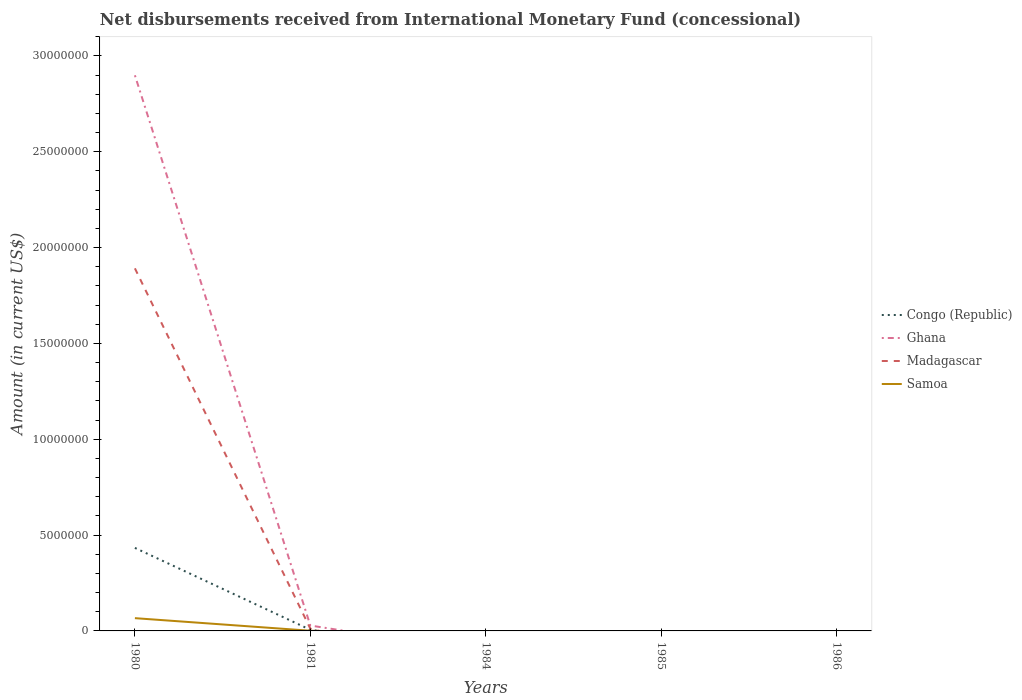How many different coloured lines are there?
Your answer should be compact. 4. Does the line corresponding to Congo (Republic) intersect with the line corresponding to Ghana?
Your response must be concise. Yes. Across all years, what is the maximum amount of disbursements received from International Monetary Fund in Madagascar?
Your answer should be compact. 0. What is the difference between the highest and the second highest amount of disbursements received from International Monetary Fund in Madagascar?
Provide a succinct answer. 1.89e+07. What is the difference between the highest and the lowest amount of disbursements received from International Monetary Fund in Congo (Republic)?
Your answer should be very brief. 1. What is the difference between two consecutive major ticks on the Y-axis?
Your answer should be compact. 5.00e+06. Are the values on the major ticks of Y-axis written in scientific E-notation?
Provide a succinct answer. No. Does the graph contain any zero values?
Ensure brevity in your answer.  Yes. Does the graph contain grids?
Make the answer very short. No. How many legend labels are there?
Your answer should be very brief. 4. What is the title of the graph?
Offer a very short reply. Net disbursements received from International Monetary Fund (concessional). What is the label or title of the X-axis?
Offer a terse response. Years. What is the Amount (in current US$) of Congo (Republic) in 1980?
Your response must be concise. 4.33e+06. What is the Amount (in current US$) in Ghana in 1980?
Provide a short and direct response. 2.90e+07. What is the Amount (in current US$) of Madagascar in 1980?
Provide a succinct answer. 1.89e+07. What is the Amount (in current US$) in Samoa in 1980?
Your answer should be compact. 6.66e+05. What is the Amount (in current US$) of Congo (Republic) in 1981?
Keep it short and to the point. 5.80e+04. What is the Amount (in current US$) in Ghana in 1981?
Give a very brief answer. 2.81e+05. What is the Amount (in current US$) in Madagascar in 1981?
Give a very brief answer. 1.16e+05. What is the Amount (in current US$) in Samoa in 1981?
Make the answer very short. 9000. What is the Amount (in current US$) of Congo (Republic) in 1984?
Your response must be concise. 0. What is the Amount (in current US$) in Ghana in 1984?
Offer a very short reply. 0. What is the Amount (in current US$) in Madagascar in 1984?
Your answer should be compact. 0. What is the Amount (in current US$) in Congo (Republic) in 1985?
Keep it short and to the point. 0. What is the Amount (in current US$) in Ghana in 1985?
Your response must be concise. 0. What is the Amount (in current US$) in Samoa in 1985?
Give a very brief answer. 0. What is the Amount (in current US$) in Congo (Republic) in 1986?
Offer a terse response. 0. What is the Amount (in current US$) of Ghana in 1986?
Provide a succinct answer. 0. What is the Amount (in current US$) in Madagascar in 1986?
Offer a terse response. 0. Across all years, what is the maximum Amount (in current US$) of Congo (Republic)?
Offer a terse response. 4.33e+06. Across all years, what is the maximum Amount (in current US$) of Ghana?
Offer a terse response. 2.90e+07. Across all years, what is the maximum Amount (in current US$) of Madagascar?
Provide a succinct answer. 1.89e+07. Across all years, what is the maximum Amount (in current US$) in Samoa?
Your response must be concise. 6.66e+05. Across all years, what is the minimum Amount (in current US$) of Congo (Republic)?
Keep it short and to the point. 0. What is the total Amount (in current US$) in Congo (Republic) in the graph?
Ensure brevity in your answer.  4.39e+06. What is the total Amount (in current US$) of Ghana in the graph?
Your answer should be compact. 2.93e+07. What is the total Amount (in current US$) in Madagascar in the graph?
Provide a succinct answer. 1.90e+07. What is the total Amount (in current US$) of Samoa in the graph?
Make the answer very short. 6.75e+05. What is the difference between the Amount (in current US$) of Congo (Republic) in 1980 and that in 1981?
Keep it short and to the point. 4.27e+06. What is the difference between the Amount (in current US$) of Ghana in 1980 and that in 1981?
Provide a short and direct response. 2.87e+07. What is the difference between the Amount (in current US$) of Madagascar in 1980 and that in 1981?
Provide a succinct answer. 1.88e+07. What is the difference between the Amount (in current US$) of Samoa in 1980 and that in 1981?
Your answer should be very brief. 6.57e+05. What is the difference between the Amount (in current US$) of Congo (Republic) in 1980 and the Amount (in current US$) of Ghana in 1981?
Your answer should be very brief. 4.05e+06. What is the difference between the Amount (in current US$) of Congo (Republic) in 1980 and the Amount (in current US$) of Madagascar in 1981?
Your answer should be compact. 4.22e+06. What is the difference between the Amount (in current US$) of Congo (Republic) in 1980 and the Amount (in current US$) of Samoa in 1981?
Your answer should be very brief. 4.32e+06. What is the difference between the Amount (in current US$) in Ghana in 1980 and the Amount (in current US$) in Madagascar in 1981?
Provide a succinct answer. 2.89e+07. What is the difference between the Amount (in current US$) in Ghana in 1980 and the Amount (in current US$) in Samoa in 1981?
Ensure brevity in your answer.  2.90e+07. What is the difference between the Amount (in current US$) of Madagascar in 1980 and the Amount (in current US$) of Samoa in 1981?
Make the answer very short. 1.89e+07. What is the average Amount (in current US$) of Congo (Republic) per year?
Your answer should be very brief. 8.78e+05. What is the average Amount (in current US$) of Ghana per year?
Provide a succinct answer. 5.85e+06. What is the average Amount (in current US$) of Madagascar per year?
Offer a terse response. 3.81e+06. What is the average Amount (in current US$) of Samoa per year?
Provide a short and direct response. 1.35e+05. In the year 1980, what is the difference between the Amount (in current US$) in Congo (Republic) and Amount (in current US$) in Ghana?
Give a very brief answer. -2.47e+07. In the year 1980, what is the difference between the Amount (in current US$) of Congo (Republic) and Amount (in current US$) of Madagascar?
Keep it short and to the point. -1.46e+07. In the year 1980, what is the difference between the Amount (in current US$) in Congo (Republic) and Amount (in current US$) in Samoa?
Your answer should be very brief. 3.67e+06. In the year 1980, what is the difference between the Amount (in current US$) in Ghana and Amount (in current US$) in Madagascar?
Offer a very short reply. 1.01e+07. In the year 1980, what is the difference between the Amount (in current US$) in Ghana and Amount (in current US$) in Samoa?
Keep it short and to the point. 2.83e+07. In the year 1980, what is the difference between the Amount (in current US$) of Madagascar and Amount (in current US$) of Samoa?
Provide a succinct answer. 1.83e+07. In the year 1981, what is the difference between the Amount (in current US$) in Congo (Republic) and Amount (in current US$) in Ghana?
Ensure brevity in your answer.  -2.23e+05. In the year 1981, what is the difference between the Amount (in current US$) of Congo (Republic) and Amount (in current US$) of Madagascar?
Your response must be concise. -5.80e+04. In the year 1981, what is the difference between the Amount (in current US$) in Congo (Republic) and Amount (in current US$) in Samoa?
Provide a short and direct response. 4.90e+04. In the year 1981, what is the difference between the Amount (in current US$) in Ghana and Amount (in current US$) in Madagascar?
Offer a terse response. 1.65e+05. In the year 1981, what is the difference between the Amount (in current US$) of Ghana and Amount (in current US$) of Samoa?
Your answer should be compact. 2.72e+05. In the year 1981, what is the difference between the Amount (in current US$) in Madagascar and Amount (in current US$) in Samoa?
Keep it short and to the point. 1.07e+05. What is the ratio of the Amount (in current US$) of Congo (Republic) in 1980 to that in 1981?
Give a very brief answer. 74.69. What is the ratio of the Amount (in current US$) in Ghana in 1980 to that in 1981?
Keep it short and to the point. 103.16. What is the ratio of the Amount (in current US$) of Madagascar in 1980 to that in 1981?
Keep it short and to the point. 163.08. What is the ratio of the Amount (in current US$) in Samoa in 1980 to that in 1981?
Give a very brief answer. 74. What is the difference between the highest and the lowest Amount (in current US$) in Congo (Republic)?
Make the answer very short. 4.33e+06. What is the difference between the highest and the lowest Amount (in current US$) of Ghana?
Your answer should be very brief. 2.90e+07. What is the difference between the highest and the lowest Amount (in current US$) of Madagascar?
Your response must be concise. 1.89e+07. What is the difference between the highest and the lowest Amount (in current US$) in Samoa?
Ensure brevity in your answer.  6.66e+05. 